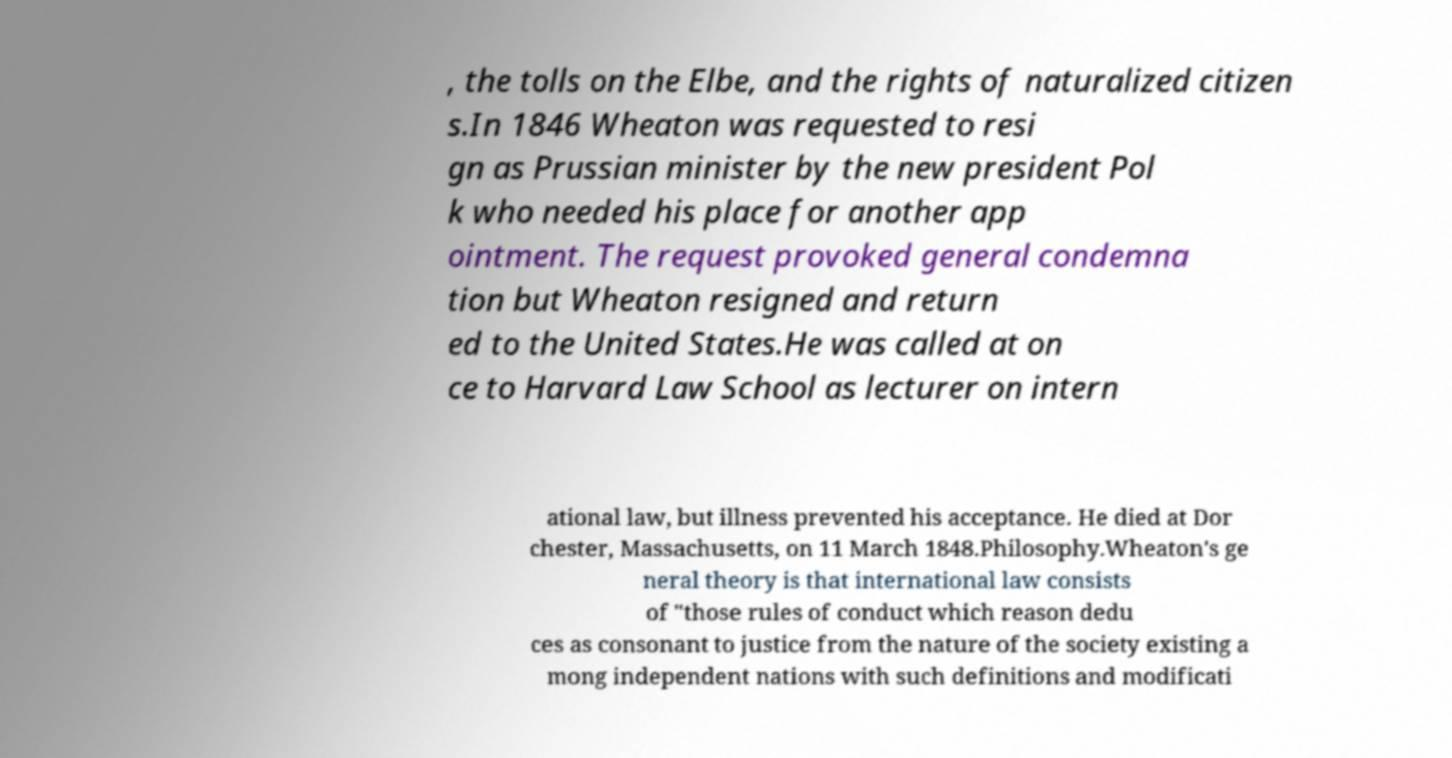Please read and relay the text visible in this image. What does it say? , the tolls on the Elbe, and the rights of naturalized citizen s.In 1846 Wheaton was requested to resi gn as Prussian minister by the new president Pol k who needed his place for another app ointment. The request provoked general condemna tion but Wheaton resigned and return ed to the United States.He was called at on ce to Harvard Law School as lecturer on intern ational law, but illness prevented his acceptance. He died at Dor chester, Massachusetts, on 11 March 1848.Philosophy.Wheaton's ge neral theory is that international law consists of "those rules of conduct which reason dedu ces as consonant to justice from the nature of the society existing a mong independent nations with such definitions and modificati 